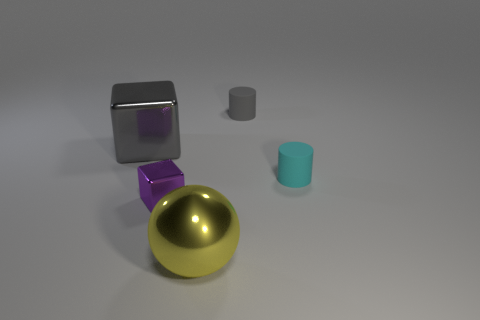What material is the object that is the same color as the large shiny cube?
Your answer should be compact. Rubber. What is the material of the other object that is the same shape as the big gray object?
Offer a very short reply. Metal. How big is the gray object right of the large thing that is to the right of the small purple object?
Make the answer very short. Small. How many other things are the same color as the sphere?
Your response must be concise. 0. What is the gray cylinder made of?
Your answer should be very brief. Rubber. Are there any gray matte objects?
Your answer should be very brief. Yes. Is the number of small purple things on the left side of the tiny purple object the same as the number of green matte cylinders?
Make the answer very short. Yes. How many tiny objects are red metal cubes or cylinders?
Make the answer very short. 2. What is the shape of the matte thing that is the same color as the big metal cube?
Your response must be concise. Cylinder. Is the big thing in front of the purple block made of the same material as the small cyan thing?
Your answer should be compact. No. 